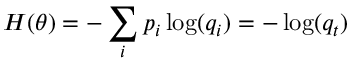<formula> <loc_0><loc_0><loc_500><loc_500>H ( \theta ) = - \sum _ { i } p _ { i } \log ( q _ { i } ) = - \log ( q _ { t } )</formula> 